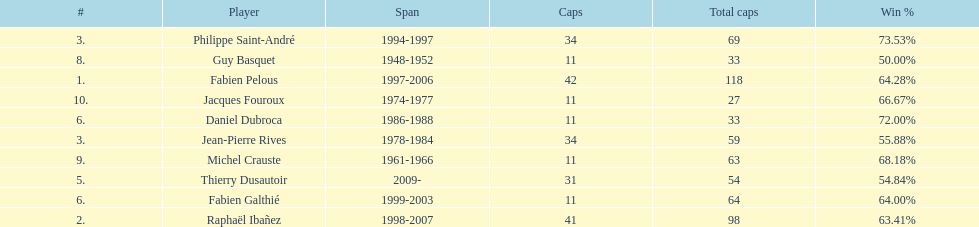How many captains played 11 capped matches? 5. Can you parse all the data within this table? {'header': ['#', 'Player', 'Span', 'Caps', 'Total caps', 'Win\xa0%'], 'rows': [['3.', 'Philippe Saint-André', '1994-1997', '34', '69', '73.53%'], ['8.', 'Guy Basquet', '1948-1952', '11', '33', '50.00%'], ['1.', 'Fabien Pelous', '1997-2006', '42', '118', '64.28%'], ['10.', 'Jacques Fouroux', '1974-1977', '11', '27', '66.67%'], ['6.', 'Daniel Dubroca', '1986-1988', '11', '33', '72.00%'], ['3.', 'Jean-Pierre Rives', '1978-1984', '34', '59', '55.88%'], ['9.', 'Michel Crauste', '1961-1966', '11', '63', '68.18%'], ['5.', 'Thierry Dusautoir', '2009-', '31', '54', '54.84%'], ['6.', 'Fabien Galthié', '1999-2003', '11', '64', '64.00%'], ['2.', 'Raphaël Ibañez', '1998-2007', '41', '98', '63.41%']]} 